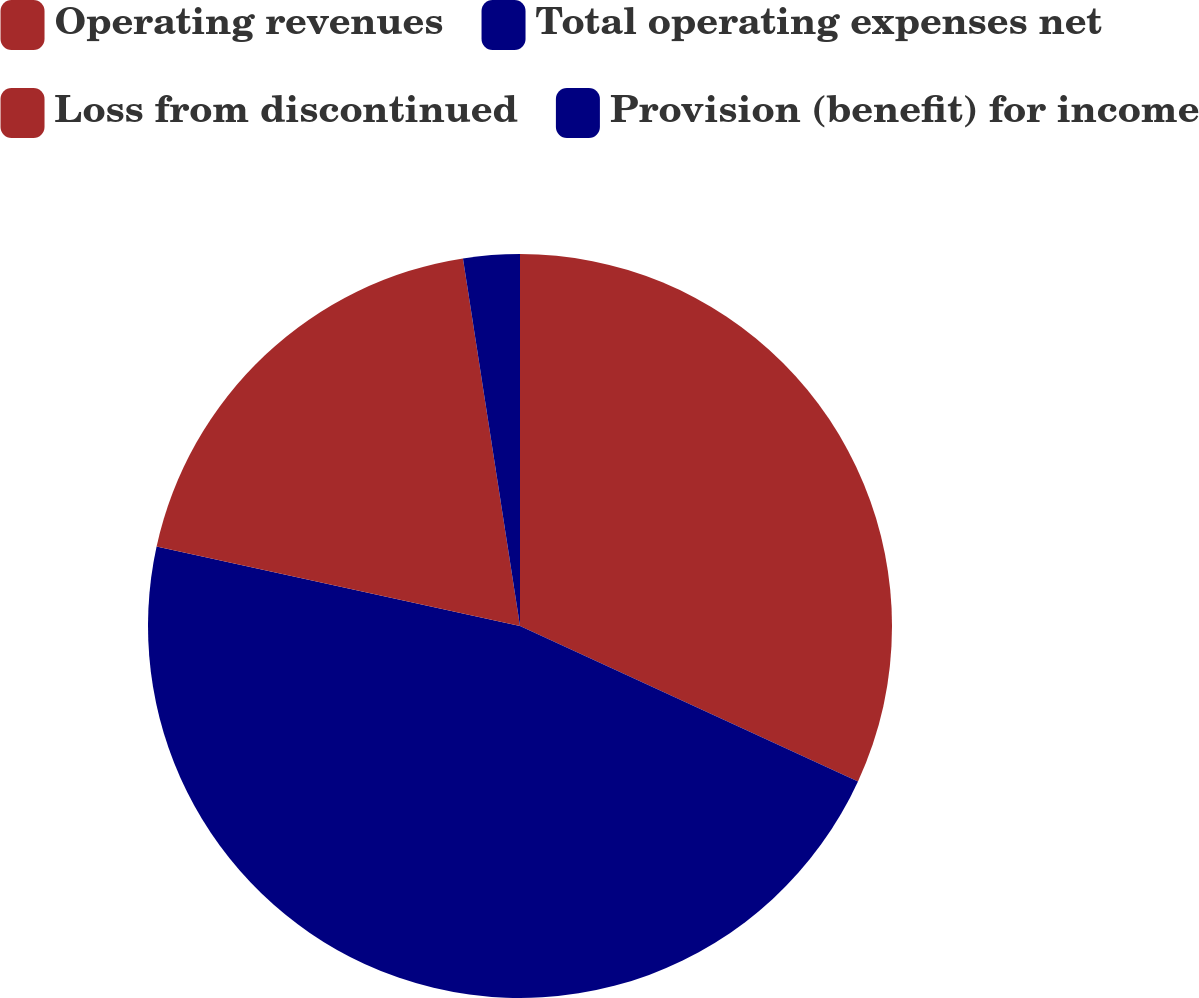<chart> <loc_0><loc_0><loc_500><loc_500><pie_chart><fcel>Operating revenues<fcel>Total operating expenses net<fcel>Loss from discontinued<fcel>Provision (benefit) for income<nl><fcel>31.86%<fcel>46.57%<fcel>19.12%<fcel>2.45%<nl></chart> 